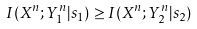<formula> <loc_0><loc_0><loc_500><loc_500>I ( X ^ { n } ; Y _ { 1 } ^ { n } | s _ { 1 } ) \geq I ( X ^ { n } ; Y _ { 2 } ^ { n } | s _ { 2 } )</formula> 